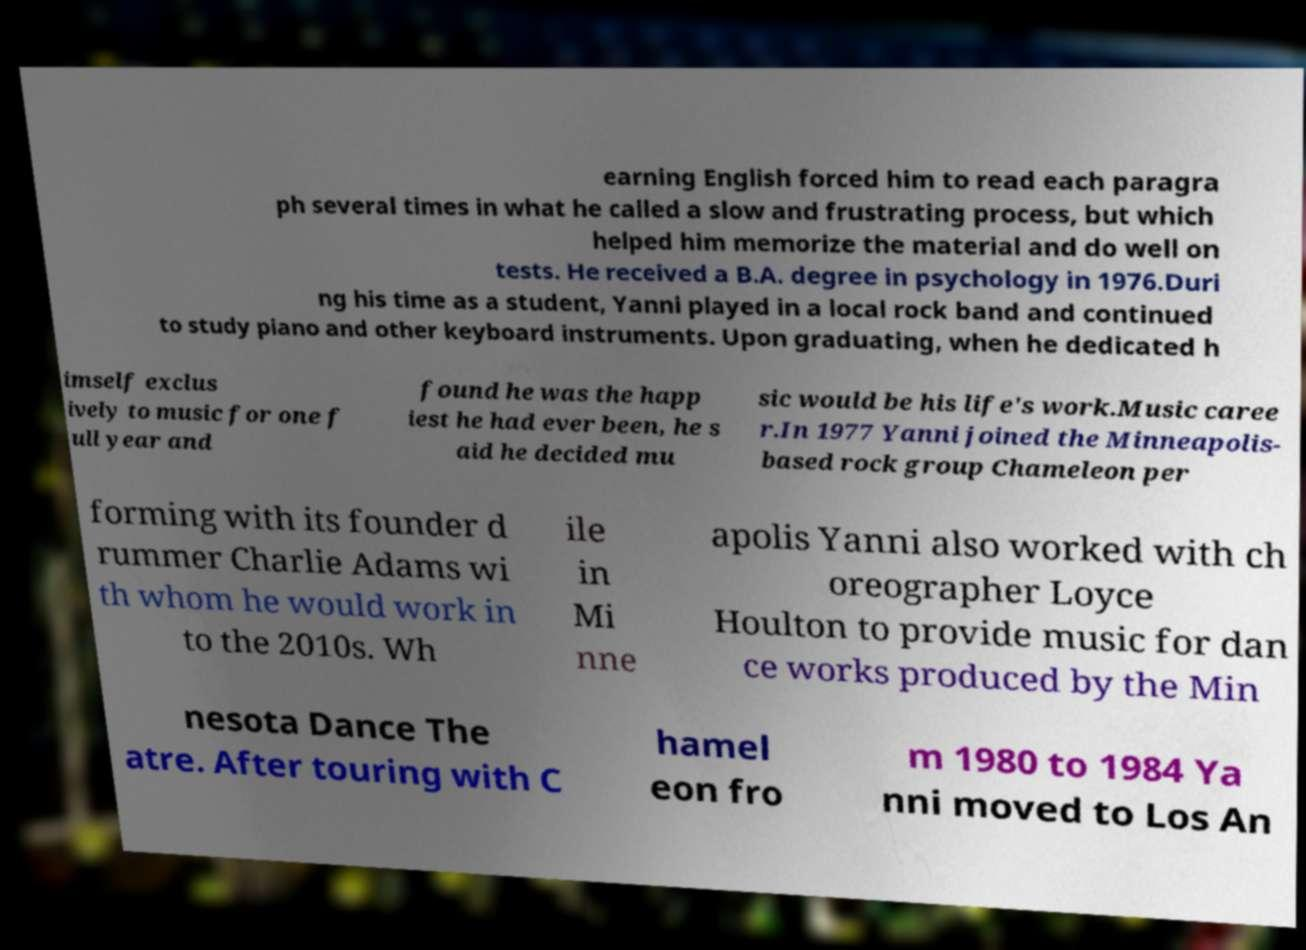What messages or text are displayed in this image? I need them in a readable, typed format. earning English forced him to read each paragra ph several times in what he called a slow and frustrating process, but which helped him memorize the material and do well on tests. He received a B.A. degree in psychology in 1976.Duri ng his time as a student, Yanni played in a local rock band and continued to study piano and other keyboard instruments. Upon graduating, when he dedicated h imself exclus ively to music for one f ull year and found he was the happ iest he had ever been, he s aid he decided mu sic would be his life's work.Music caree r.In 1977 Yanni joined the Minneapolis- based rock group Chameleon per forming with its founder d rummer Charlie Adams wi th whom he would work in to the 2010s. Wh ile in Mi nne apolis Yanni also worked with ch oreographer Loyce Houlton to provide music for dan ce works produced by the Min nesota Dance The atre. After touring with C hamel eon fro m 1980 to 1984 Ya nni moved to Los An 